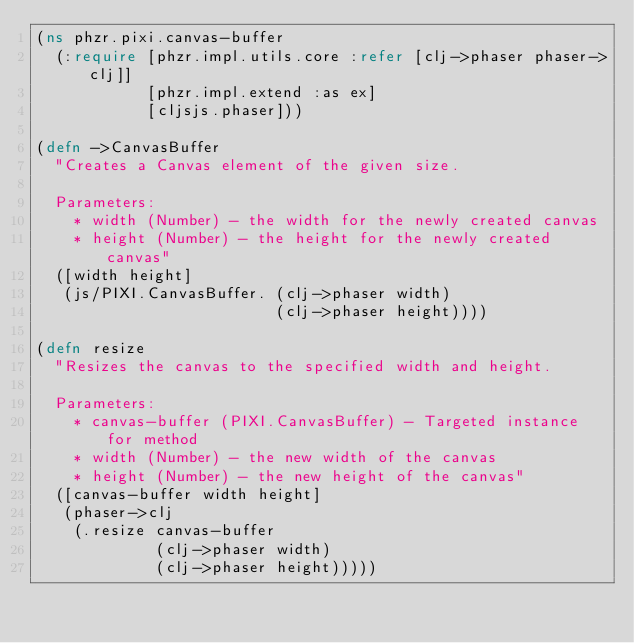<code> <loc_0><loc_0><loc_500><loc_500><_Clojure_>(ns phzr.pixi.canvas-buffer
  (:require [phzr.impl.utils.core :refer [clj->phaser phaser->clj]]
            [phzr.impl.extend :as ex]
            [cljsjs.phaser]))

(defn ->CanvasBuffer
  "Creates a Canvas element of the given size.

  Parameters:
    * width (Number) - the width for the newly created canvas
    * height (Number) - the height for the newly created canvas"
  ([width height]
   (js/PIXI.CanvasBuffer. (clj->phaser width)
                          (clj->phaser height))))

(defn resize
  "Resizes the canvas to the specified width and height.

  Parameters:
    * canvas-buffer (PIXI.CanvasBuffer) - Targeted instance for method
    * width (Number) - the new width of the canvas
    * height (Number) - the new height of the canvas"
  ([canvas-buffer width height]
   (phaser->clj
    (.resize canvas-buffer
             (clj->phaser width)
             (clj->phaser height)))))</code> 